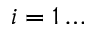Convert formula to latex. <formula><loc_0><loc_0><loc_500><loc_500>i = 1 \dots</formula> 